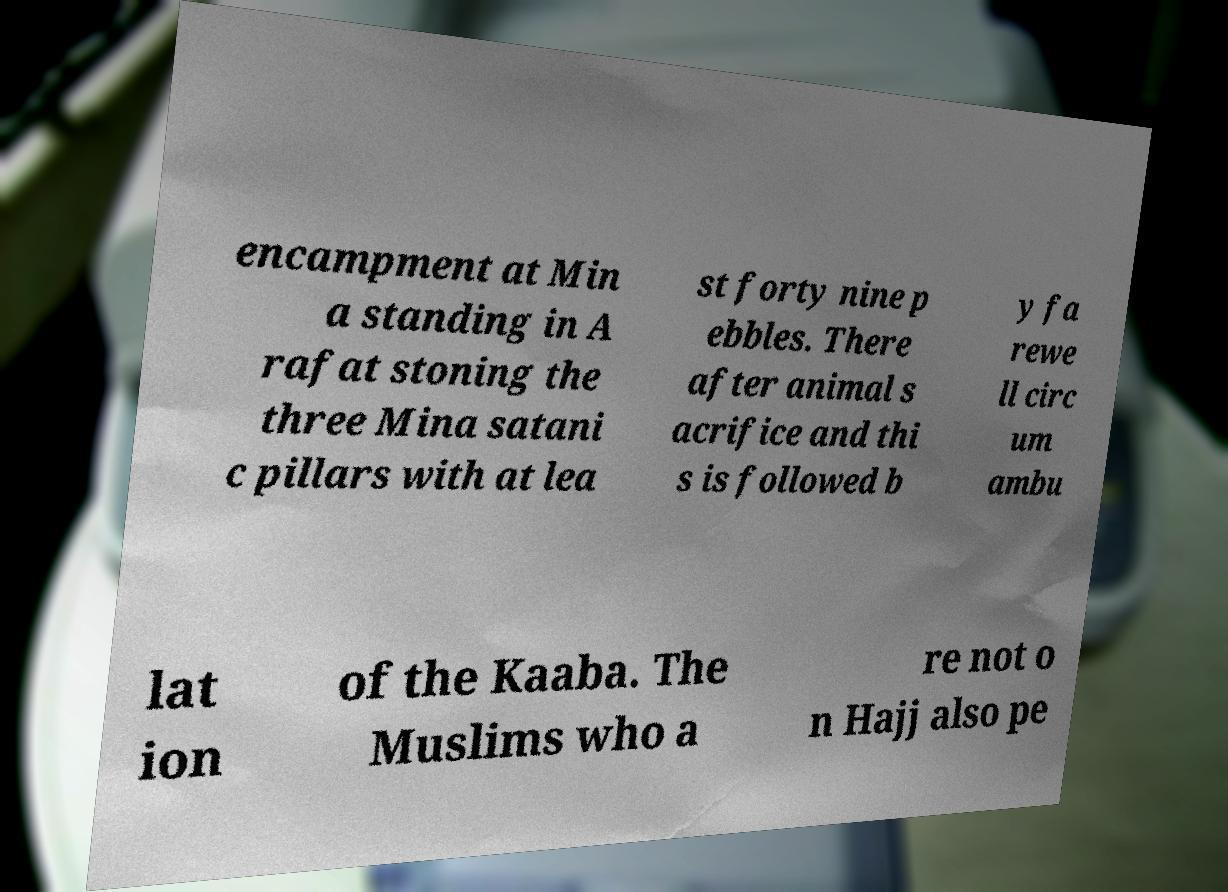I need the written content from this picture converted into text. Can you do that? encampment at Min a standing in A rafat stoning the three Mina satani c pillars with at lea st forty nine p ebbles. There after animal s acrifice and thi s is followed b y fa rewe ll circ um ambu lat ion of the Kaaba. The Muslims who a re not o n Hajj also pe 